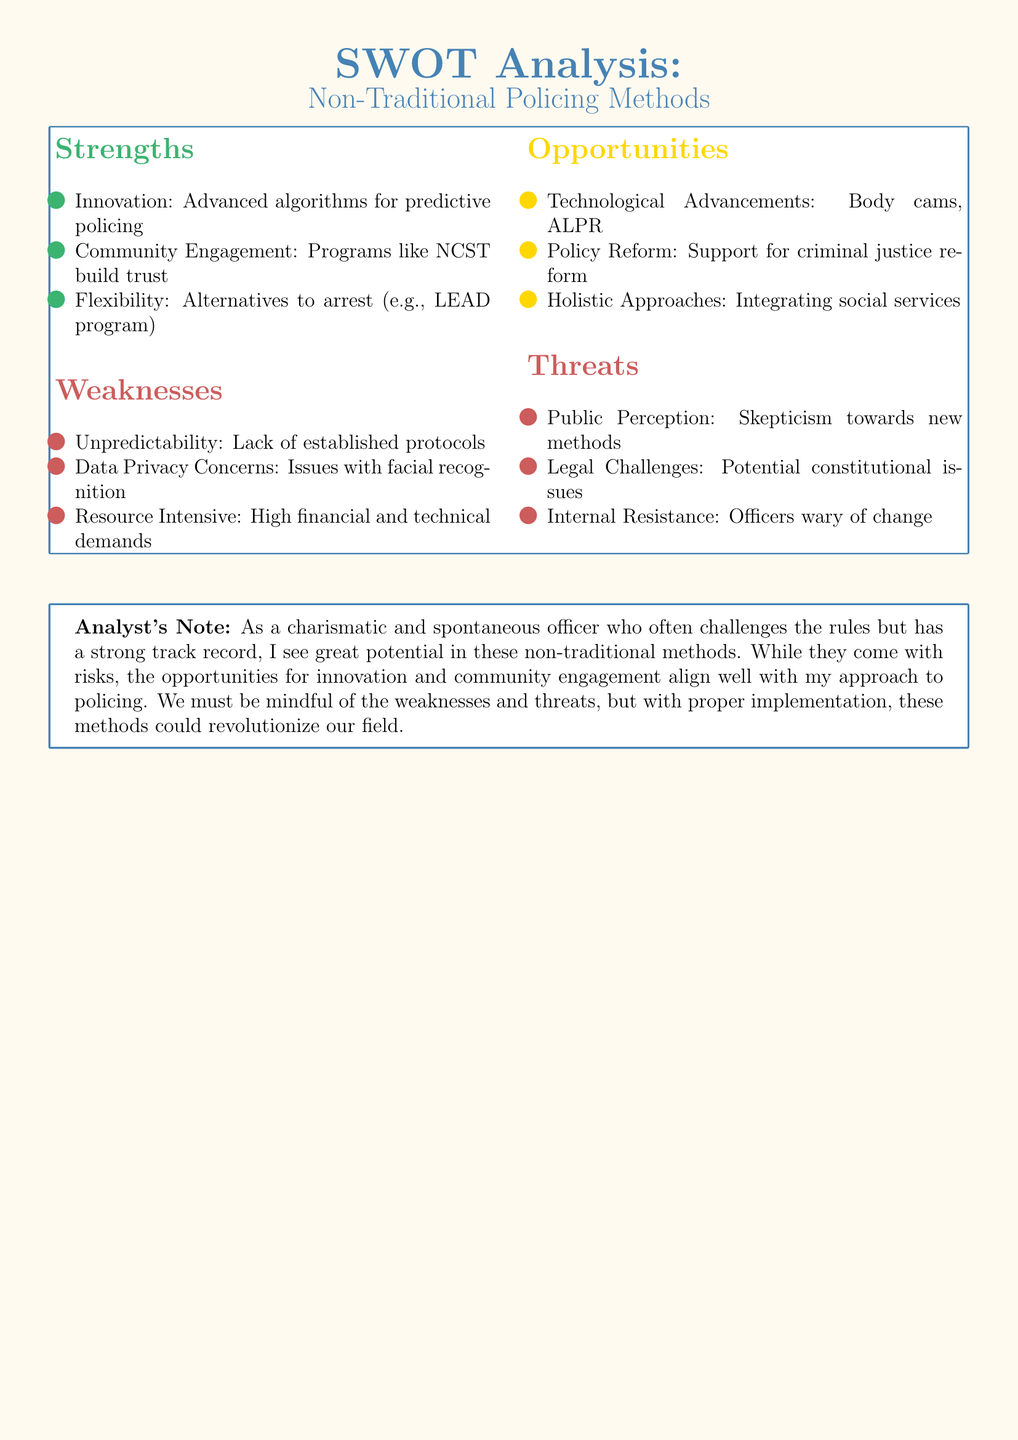What is one strength of non-traditional policing methods? The document lists several strengths, one of which is innovation through advanced algorithms for predictive policing.
Answer: Innovation: Advanced algorithms for predictive policing What is a weakness related to data in the document? The document mentions data privacy concerns, which relates to issues with facial recognition technology being used in policing.
Answer: Data Privacy Concerns: Issues with facial recognition Identify one opportunity presented in the SWOT analysis. The document highlights several opportunities, such as technological advancements like body cams and ALPR.
Answer: Technological Advancements: Body cams, ALPR What threat involves public perception? According to the document, skepticism towards new methods can impact how the public perceives non-traditional policing.
Answer: Public Perception: Skepticism towards new methods How many strengths are listed in the strengths section? The document contains three items listed under strengths for non-traditional policing methods.
Answer: Three Which program is mentioned as an alternative to arrest in the strengths section? The document mentions the LEAD program as an example of an alternative to arrest.
Answer: LEAD program What is a cited opportunity for policy in the document? The document notes that policy reform is an opportunity that supports criminal justice reform initiatives.
Answer: Policy Reform: Support for criminal justice reform What is a noted threat regarding officer attitudes? Internal resistance is acknowledged in the document as a threat due to officers being wary of change.
Answer: Internal Resistance: Officers wary of change Which section discusses community engagement? The strengths section outlines community engagement programs like NCST that help build trust.
Answer: Community Engagement: Programs like NCST build trust 